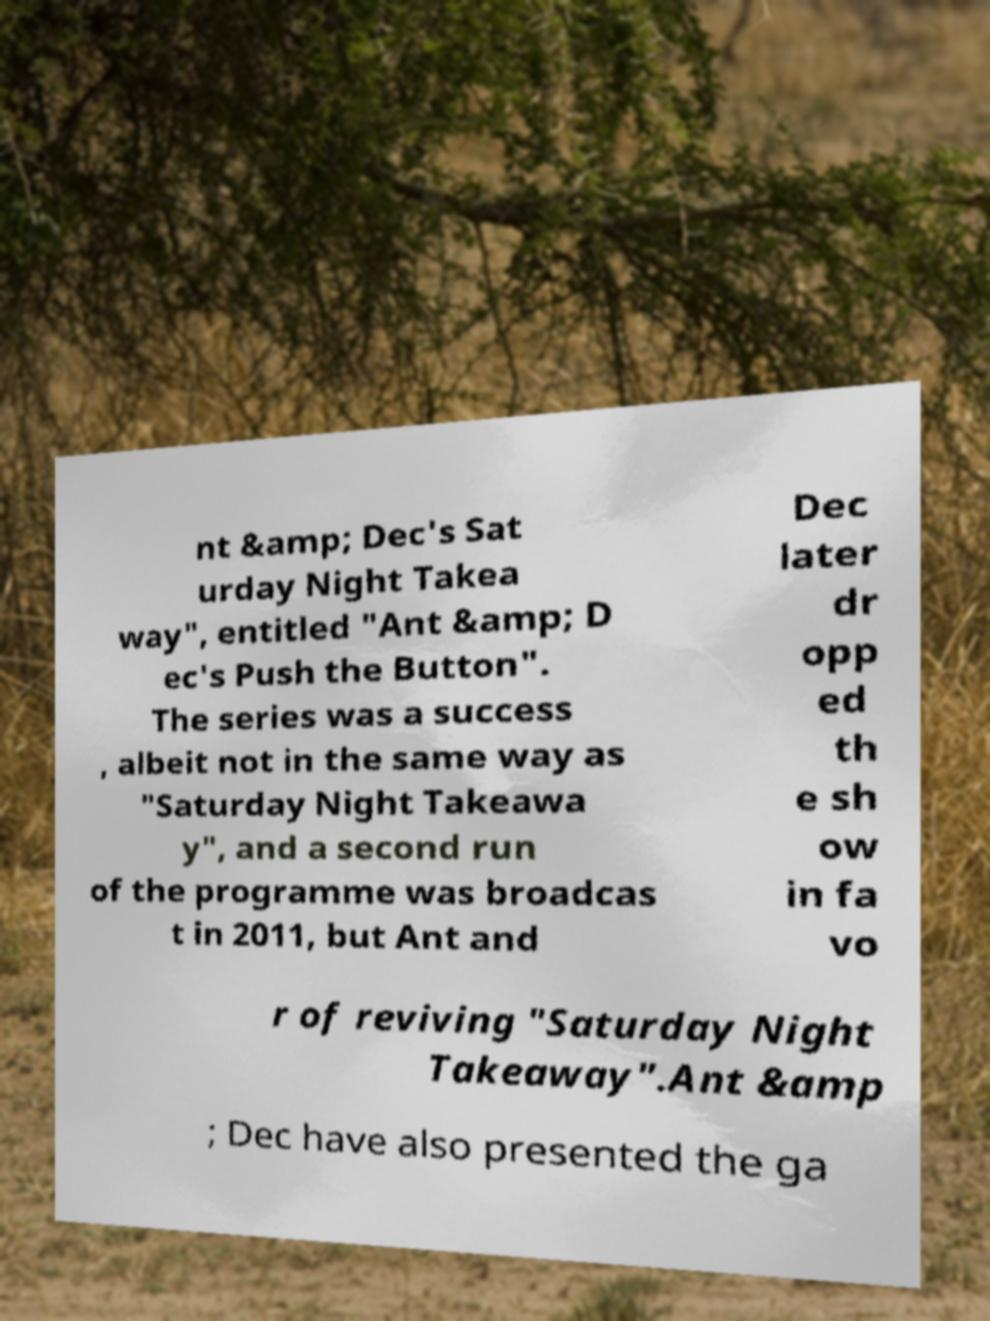Can you read and provide the text displayed in the image?This photo seems to have some interesting text. Can you extract and type it out for me? nt &amp; Dec's Sat urday Night Takea way", entitled "Ant &amp; D ec's Push the Button". The series was a success , albeit not in the same way as "Saturday Night Takeawa y", and a second run of the programme was broadcas t in 2011, but Ant and Dec later dr opp ed th e sh ow in fa vo r of reviving "Saturday Night Takeaway".Ant &amp ; Dec have also presented the ga 